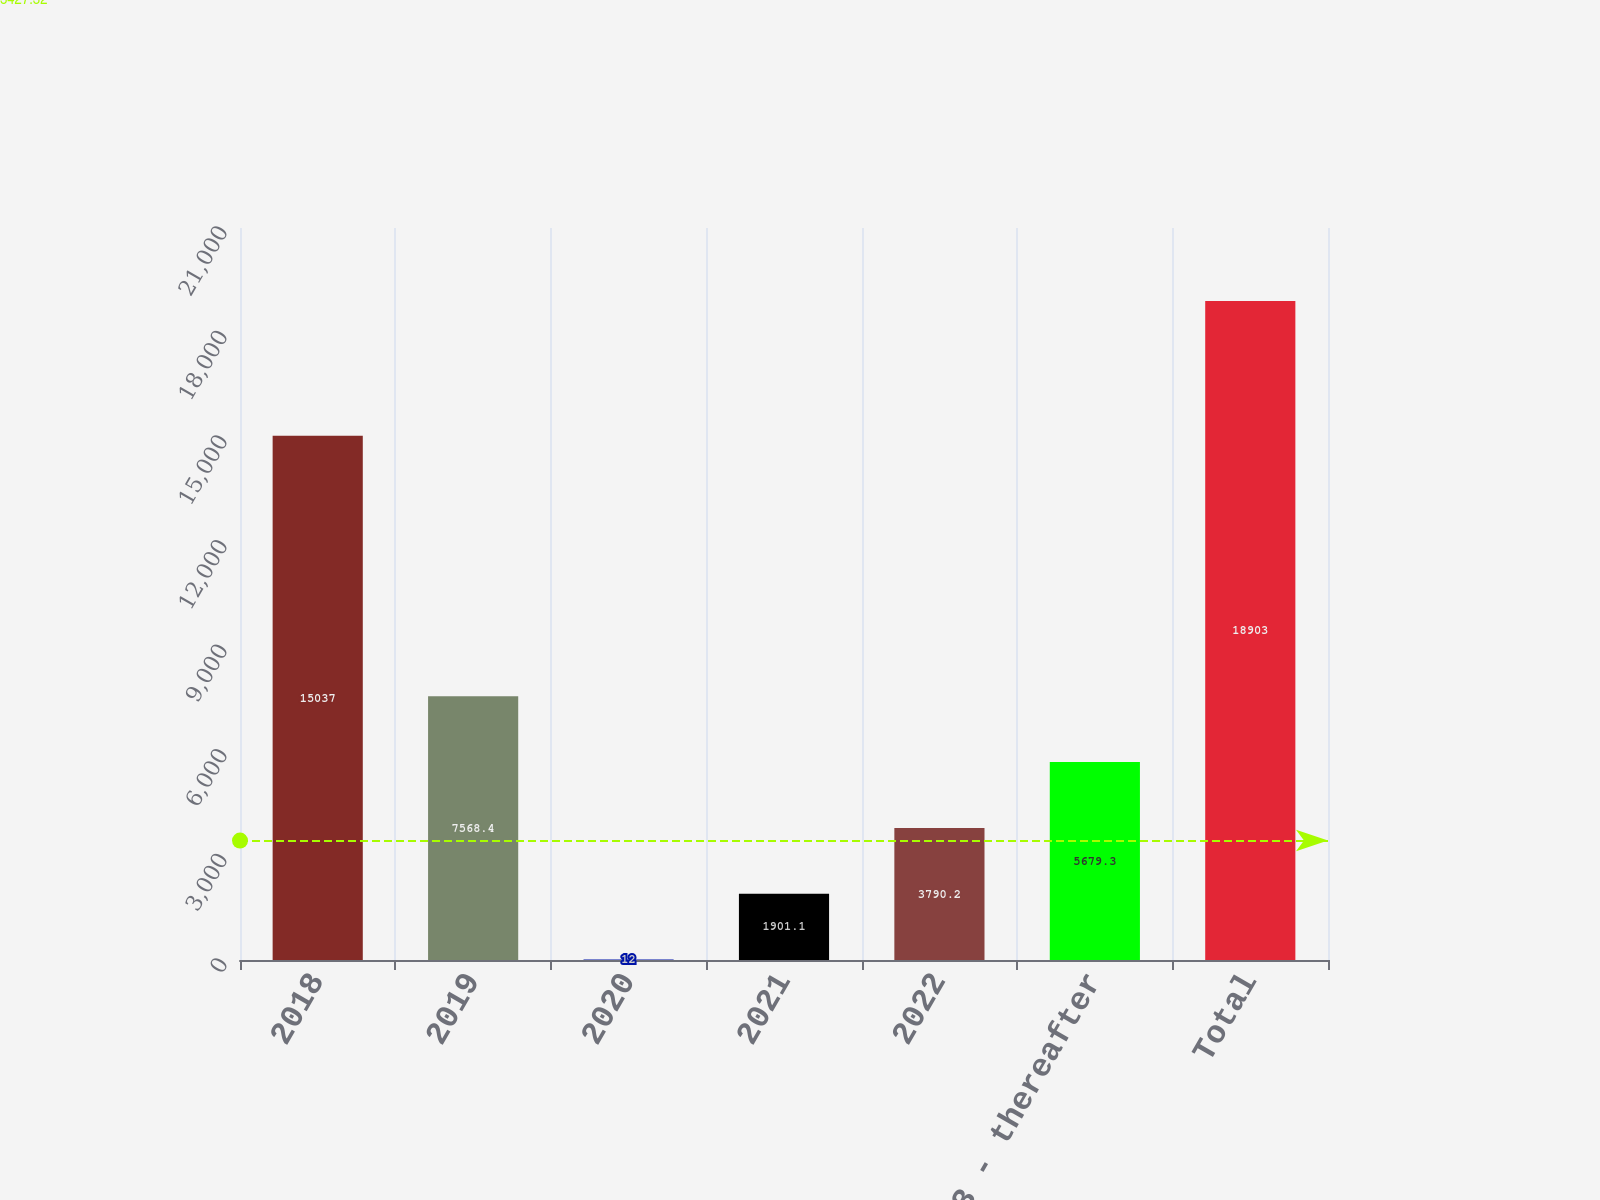Convert chart. <chart><loc_0><loc_0><loc_500><loc_500><bar_chart><fcel>2018<fcel>2019<fcel>2020<fcel>2021<fcel>2022<fcel>2023 - thereafter<fcel>Total<nl><fcel>15037<fcel>7568.4<fcel>12<fcel>1901.1<fcel>3790.2<fcel>5679.3<fcel>18903<nl></chart> 